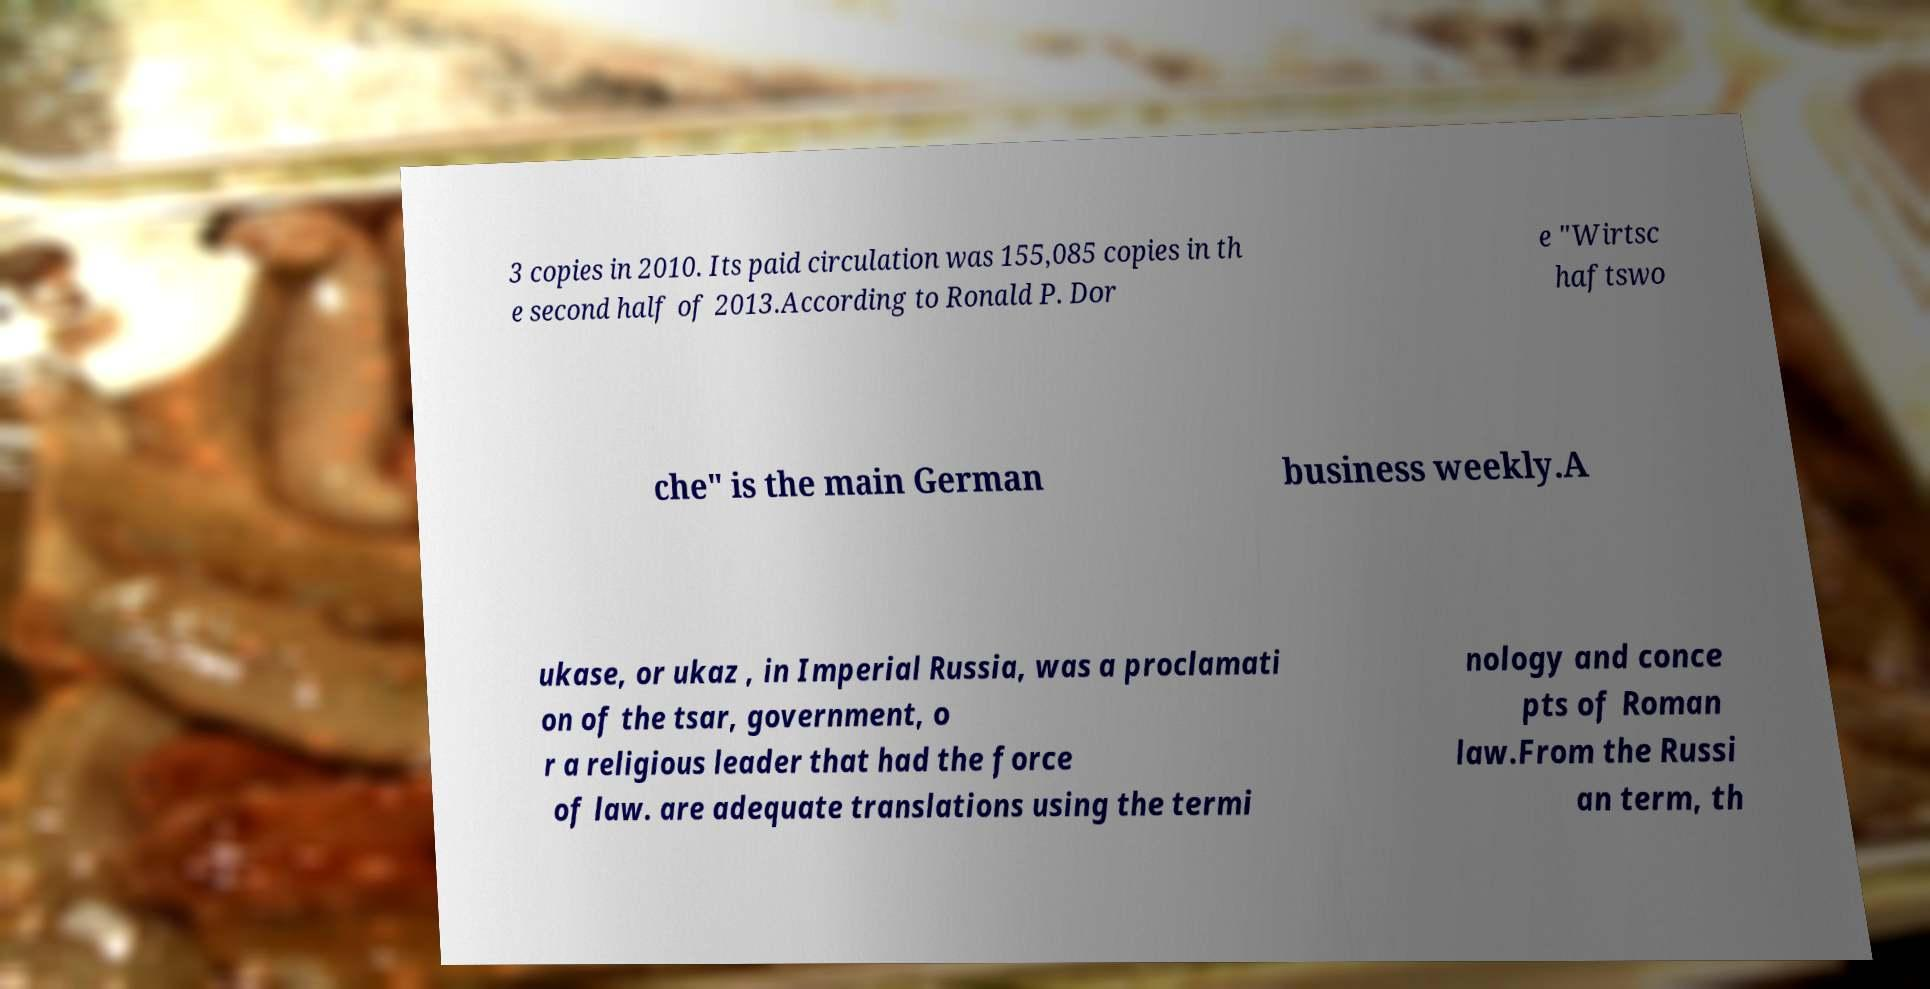What messages or text are displayed in this image? I need them in a readable, typed format. 3 copies in 2010. Its paid circulation was 155,085 copies in th e second half of 2013.According to Ronald P. Dor e "Wirtsc haftswo che" is the main German business weekly.A ukase, or ukaz , in Imperial Russia, was a proclamati on of the tsar, government, o r a religious leader that had the force of law. are adequate translations using the termi nology and conce pts of Roman law.From the Russi an term, th 